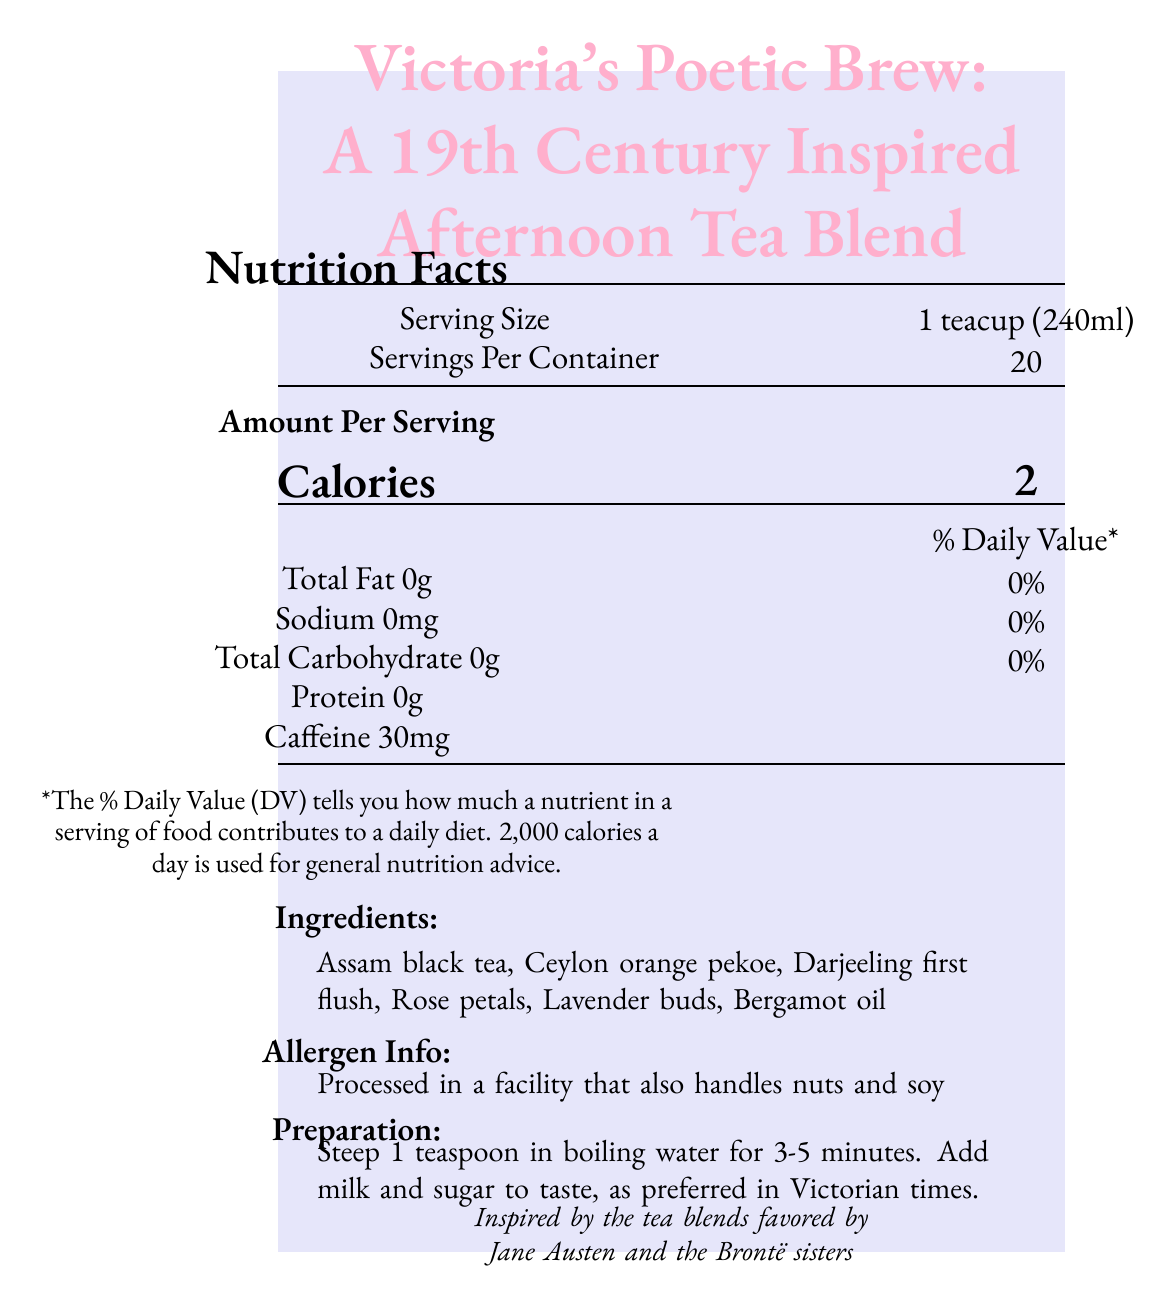what is the serving size? The serving size is clearly stated as "1 teacup (240ml)" in the document.
Answer: 1 teacup (240ml) how many servings are there per container? The label specifies that there are 20 servings per container.
Answer: 20 how many calories are in one serving? The document indicates that each serving has 2 calories.
Answer: 2 how much caffeine is in one serving? The label states that one serving contains 30mg of caffeine.
Answer: 30mg what are the main ingredients of the tea blend? The ingredients list includes all these items.
Answer: Assam black tea, Ceylon orange pekoe, Darjeeling first flush, Rose petals, Lavender buds, Bergamot oil is there any protein in one serving? According to the document, each serving contains 0 grams of protein.
Answer: No is this product suitable for people allergic to nuts or soy? The allergen info states that it is processed in a facility that handles nuts and soy.
Answer: No how should Victoria's Poetic Brew be prepared? The preparation instructions specify to steep 1 teaspoon in boiling water for 3-5 minutes and add milk and sugar if desired.
Answer: Steep 1 teaspoon in boiling water for 3-5 minutes. Add milk and sugar to taste. what literature is recommended to pair with this tea? The literary pairing suggests enjoying this tea while reading 'Wuthering Heights' by Emily Brontë.
Answer: 'Wuthering Heights' by Emily Brontë what is the total fat content per serving? The document indicates that there is 0 grams of total fat per serving.
Answer: 0g how much sodium is in each serving? The label notes that each serving contains 0mg of sodium.
Answer: 0mg what note is inspired by Jane Austen and the Brontë sisters? The cultural note mentions that the tea blend is inspired by the tea blends favored by Jane Austen and the Brontë sisters.
Answer: Cultural Note what is the percentage of the daily value for total fat? The document states that the daily value for total fat is 0%.
Answer: 0% what is the product name of this tea? A. Victorian Afternoon Bliss B. Victoria's Poetic Brew C. Jane Austen's Blend D. Bronte Sisters' Brew The product name given is Victoria's Poetic Brew.
Answer: B how many minutes are recommended to steep the tea? A. 1-2 minutes B. 2-4 minutes C. 3-5 minutes D. 5-7 minutes The preparation instructions specify 3-5 minutes for steeping.
Answer: C is the tea blend's package reusable? The document mentions that the packaging comes in a reusable tin.
Answer: Yes briefly summarize the main features of Victoria's Poetic Brew. The summary covers the product name, serving size, nutritional content, ingredients, allergen information, and the suggested literary pairing.
Answer: Victoria's Poetic Brew is a 19th Century Inspired Afternoon Tea Blend that comes in a 240ml serving size with 20 servings per container. Each serving has 2 calories, 30mg of caffeine, and no fat, sodium, carbohydrates, or protein. The tea blend includes Assam black tea, Ceylon orange pekoe, Darjeeling first flush, rose petals, lavender buds, and bergamot oil. It is processed in a facility that handles nuts and soy and is recommended to be enjoyed while reading 'Wuthering Heights' by Emily Brontë. how much sugar can be found in each serving? The document does not provide information about the sugar content in each serving.
Answer: Not enough information 